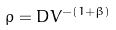Convert formula to latex. <formula><loc_0><loc_0><loc_500><loc_500>\rho = D V ^ { - ( 1 + \beta ) }</formula> 